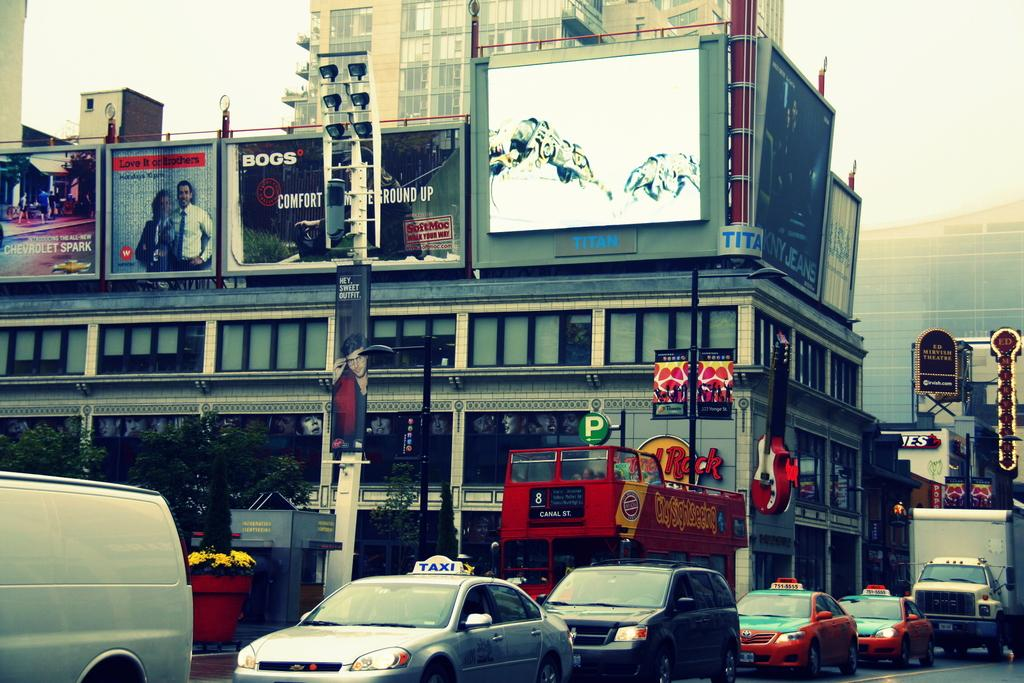<image>
Give a short and clear explanation of the subsequent image. A row of cars are going down the street next to a building with a sign that says Titan. 